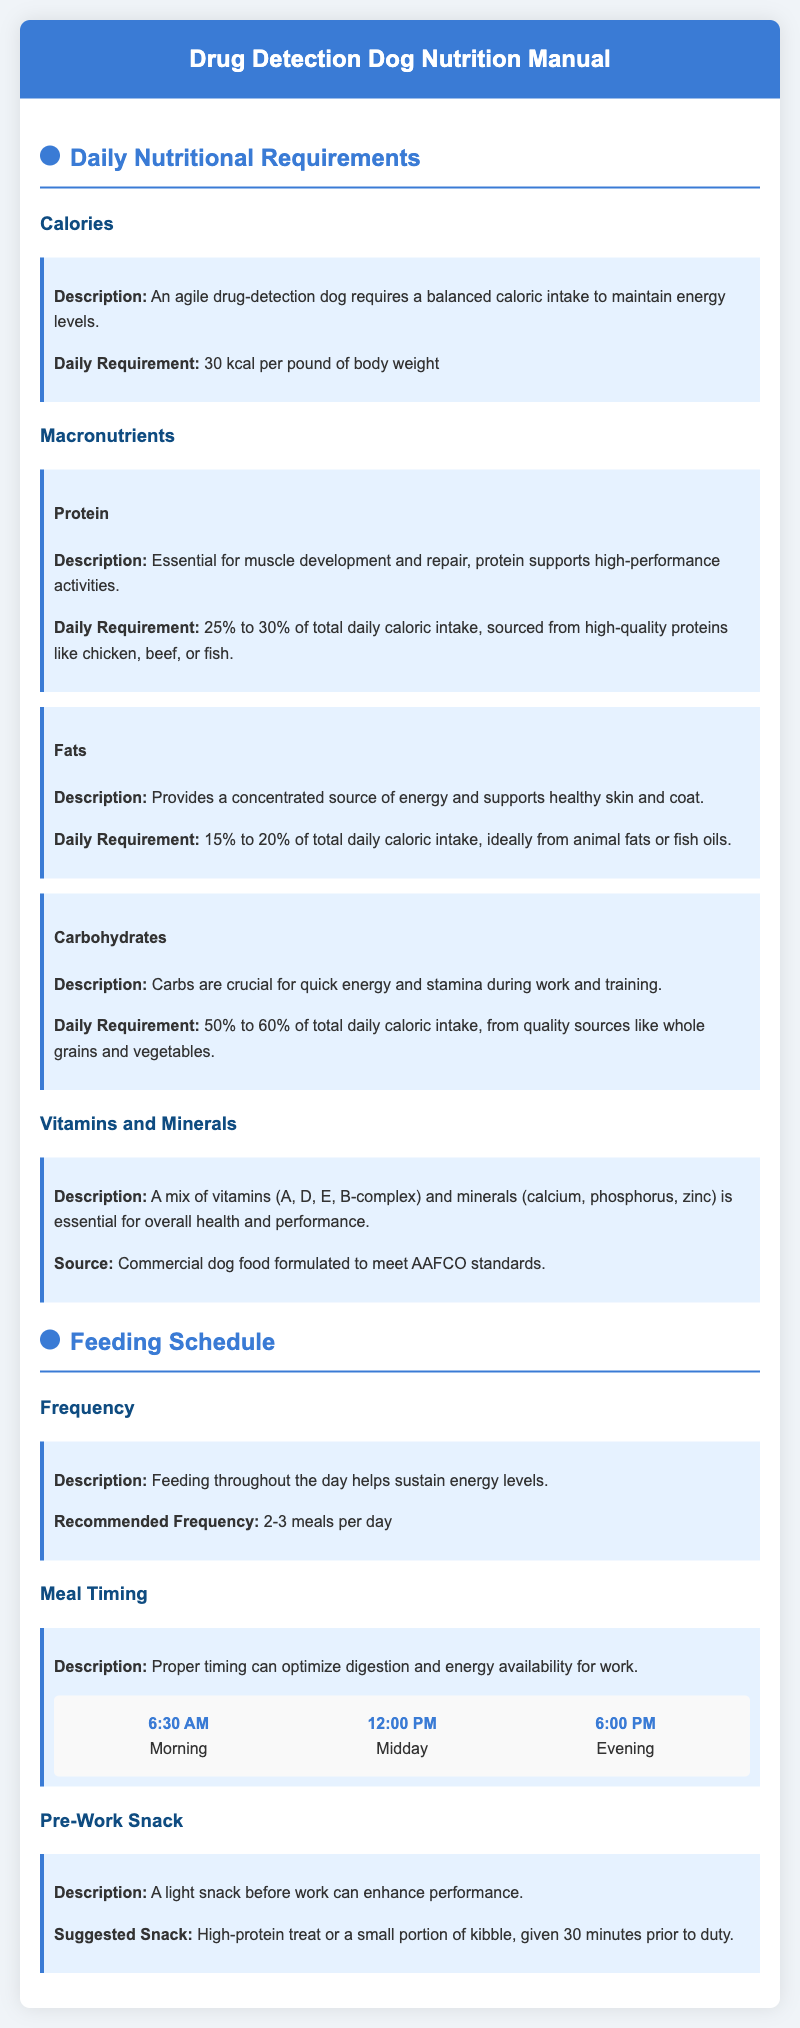what is the daily caloric requirement for a drug-detection dog? The daily caloric requirement is specified as 30 kcal per pound of body weight, which is essential for maintaining energy levels.
Answer: 30 kcal per pound what percentage of daily caloric intake should come from protein? The document states that 25% to 30% of the total daily caloric intake should come from protein, which is crucial for muscle development and repair.
Answer: 25% to 30% what are the recommended feeding frequencies throughout the day? The manual recommends feeding the dog 2-3 meals per day to sustain energy levels.
Answer: 2-3 meals per day at what time is the evening meal suggested? The schedule suggests that the evening meal should be at 6:00 PM, optimizing digestion and energy availability for work.
Answer: 6:00 PM what type of treat is suggested for a pre-work snack? A high-protein treat or a small portion of kibble is suggested for a light snack 30 minutes prior to duty.
Answer: High-protein treat or kibble how does fat contribute to a drug-detection dog's nutrition? Fat provides a concentrated source of energy and supports healthy skin and coat, making it an essential macronutrient for performance.
Answer: Concentrated source of energy what is the main source for necessary vitamins and minerals? The document indicates that a commercial dog food formulated to meet AAFCO standards is the primary source for the required vitamins and minerals.
Answer: Commercial dog food why is timing of meals important according to the manual? Proper timing of meals can optimize digestion and energy availability, enhancing the dog's performance during work and training.
Answer: Optimize digestion and energy availability what macronutrient is critical for quick energy and stamina? Carbohydrates are identified as crucial for quick energy and stamina during work and training activities.
Answer: Carbohydrates 